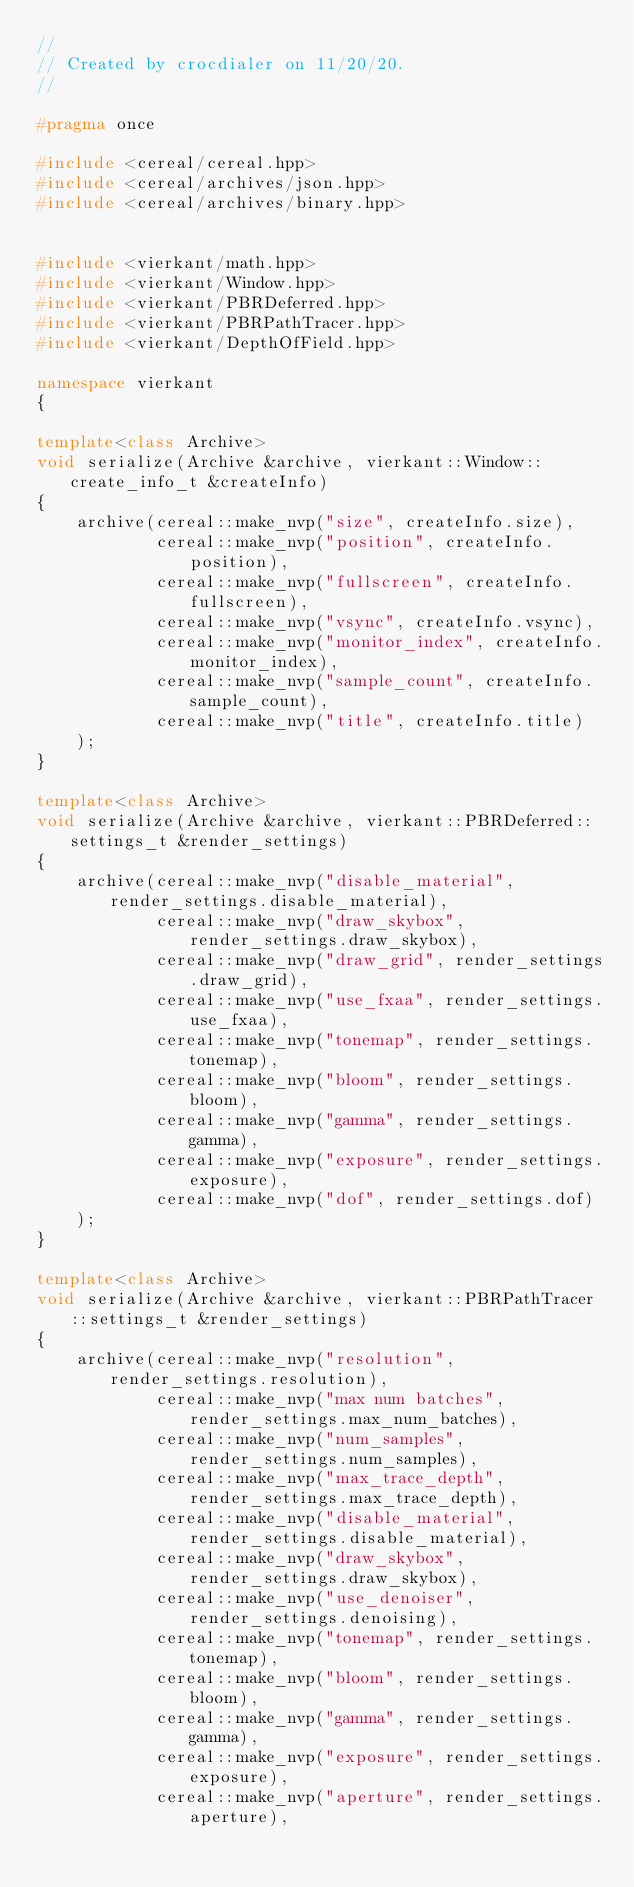<code> <loc_0><loc_0><loc_500><loc_500><_C++_>//
// Created by crocdialer on 11/20/20.
//

#pragma once

#include <cereal/cereal.hpp>
#include <cereal/archives/json.hpp>
#include <cereal/archives/binary.hpp>


#include <vierkant/math.hpp>
#include <vierkant/Window.hpp>
#include <vierkant/PBRDeferred.hpp>
#include <vierkant/PBRPathTracer.hpp>
#include <vierkant/DepthOfField.hpp>

namespace vierkant
{

template<class Archive>
void serialize(Archive &archive, vierkant::Window::create_info_t &createInfo)
{
    archive(cereal::make_nvp("size", createInfo.size),
            cereal::make_nvp("position", createInfo.position),
            cereal::make_nvp("fullscreen", createInfo.fullscreen),
            cereal::make_nvp("vsync", createInfo.vsync),
            cereal::make_nvp("monitor_index", createInfo.monitor_index),
            cereal::make_nvp("sample_count", createInfo.sample_count),
            cereal::make_nvp("title", createInfo.title)
    );
}

template<class Archive>
void serialize(Archive &archive, vierkant::PBRDeferred::settings_t &render_settings)
{
    archive(cereal::make_nvp("disable_material", render_settings.disable_material),
            cereal::make_nvp("draw_skybox", render_settings.draw_skybox),
            cereal::make_nvp("draw_grid", render_settings.draw_grid),
            cereal::make_nvp("use_fxaa", render_settings.use_fxaa),
            cereal::make_nvp("tonemap", render_settings.tonemap),
            cereal::make_nvp("bloom", render_settings.bloom),
            cereal::make_nvp("gamma", render_settings.gamma),
            cereal::make_nvp("exposure", render_settings.exposure),
            cereal::make_nvp("dof", render_settings.dof)
    );
}

template<class Archive>
void serialize(Archive &archive, vierkant::PBRPathTracer::settings_t &render_settings)
{
    archive(cereal::make_nvp("resolution", render_settings.resolution),
            cereal::make_nvp("max num batches", render_settings.max_num_batches),
            cereal::make_nvp("num_samples", render_settings.num_samples),
            cereal::make_nvp("max_trace_depth", render_settings.max_trace_depth),
            cereal::make_nvp("disable_material", render_settings.disable_material),
            cereal::make_nvp("draw_skybox", render_settings.draw_skybox),
            cereal::make_nvp("use_denoiser", render_settings.denoising),
            cereal::make_nvp("tonemap", render_settings.tonemap),
            cereal::make_nvp("bloom", render_settings.bloom),
            cereal::make_nvp("gamma", render_settings.gamma),
            cereal::make_nvp("exposure", render_settings.exposure),
            cereal::make_nvp("aperture", render_settings.aperture),</code> 